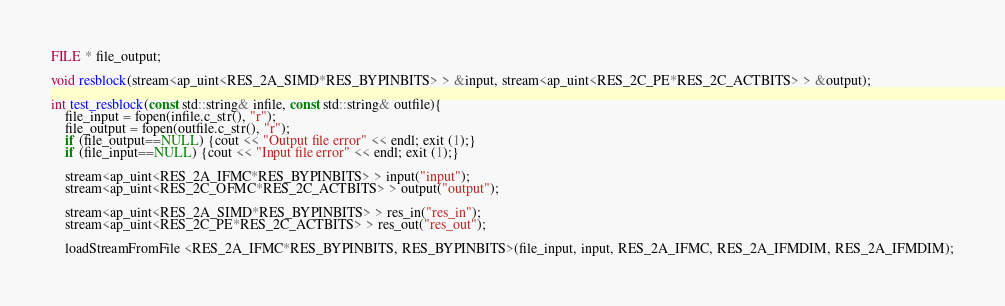<code> <loc_0><loc_0><loc_500><loc_500><_C++_>FILE * file_output;

void resblock(stream<ap_uint<RES_2A_SIMD*RES_BYPINBITS> > &input, stream<ap_uint<RES_2C_PE*RES_2C_ACTBITS> > &output);

int test_resblock(const std::string& infile, const std::string& outfile){
    file_input = fopen(infile.c_str(), "r");
    file_output = fopen(outfile.c_str(), "r");
    if (file_output==NULL) {cout << "Output file error" << endl; exit (1);}
    if (file_input==NULL) {cout << "Input file error" << endl; exit (1);}
    
    stream<ap_uint<RES_2A_IFMC*RES_BYPINBITS> > input("input");
    stream<ap_uint<RES_2C_OFMC*RES_2C_ACTBITS> > output("output");
    
    stream<ap_uint<RES_2A_SIMD*RES_BYPINBITS> > res_in("res_in");
    stream<ap_uint<RES_2C_PE*RES_2C_ACTBITS> > res_out("res_out");

    loadStreamFromFile <RES_2A_IFMC*RES_BYPINBITS, RES_BYPINBITS>(file_input, input, RES_2A_IFMC, RES_2A_IFMDIM, RES_2A_IFMDIM);
</code> 